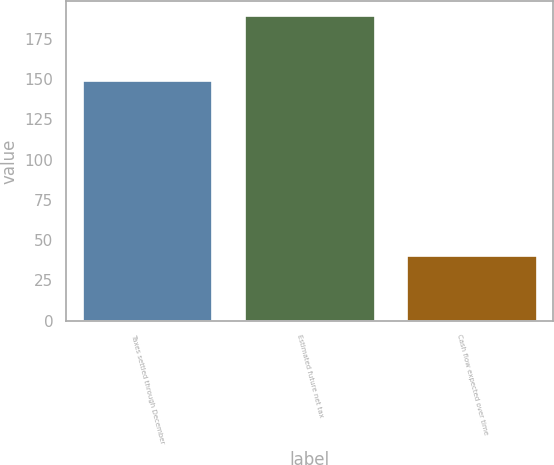<chart> <loc_0><loc_0><loc_500><loc_500><bar_chart><fcel>Taxes settled through December<fcel>Estimated future net tax<fcel>Cash flow expected over time<nl><fcel>149<fcel>189<fcel>40<nl></chart> 